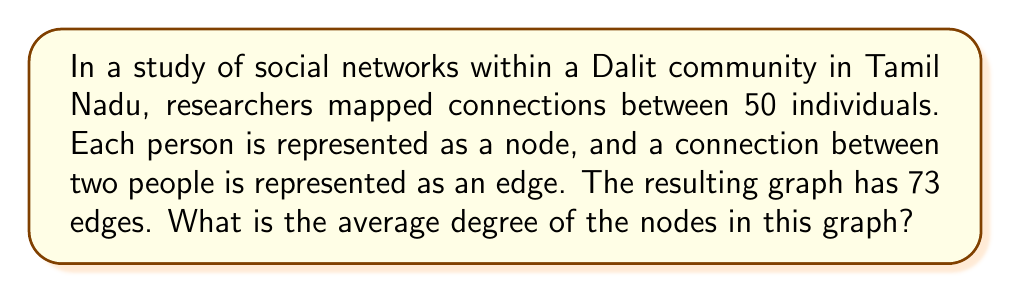What is the answer to this math problem? To solve this problem, we'll use concepts from graph theory:

1. In an undirected graph, each edge connects two nodes.

2. The degree of a node is the number of edges connected to it.

3. The sum of all node degrees in a graph is equal to twice the number of edges. This is because each edge contributes to the degree of two nodes.

4. The average degree is the sum of all degrees divided by the number of nodes.

Let's apply these concepts to our problem:

1. Number of nodes (n) = 50
2. Number of edges (e) = 73

3. Sum of all degrees = 2 * number of edges
   $$ \sum_{i=1}^n \text{degree}(v_i) = 2e = 2 * 73 = 146 $$

4. Average degree = Sum of all degrees / Number of nodes
   $$ \text{Average degree} = \frac{\sum_{i=1}^n \text{degree}(v_i)}{n} = \frac{146}{50} = 2.92 $$

Therefore, the average degree of the nodes in this graph is 2.92.
Answer: 2.92 